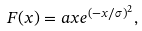Convert formula to latex. <formula><loc_0><loc_0><loc_500><loc_500>F ( x ) = a x e ^ { ( - x / \sigma ) ^ { 2 } } ,</formula> 